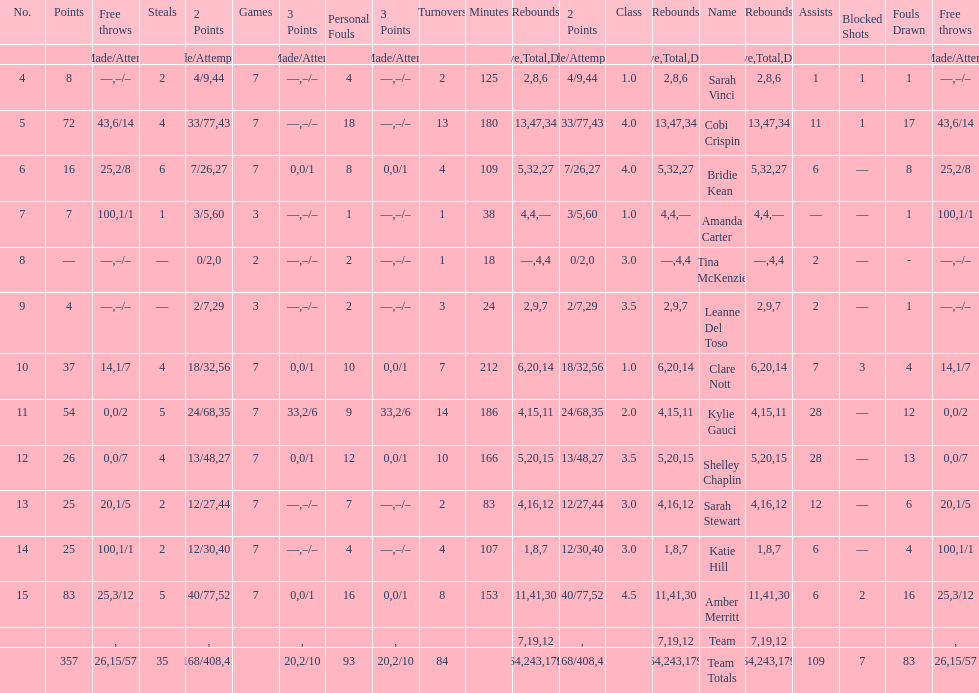Who had more steals than any other player? Bridie Kean. 